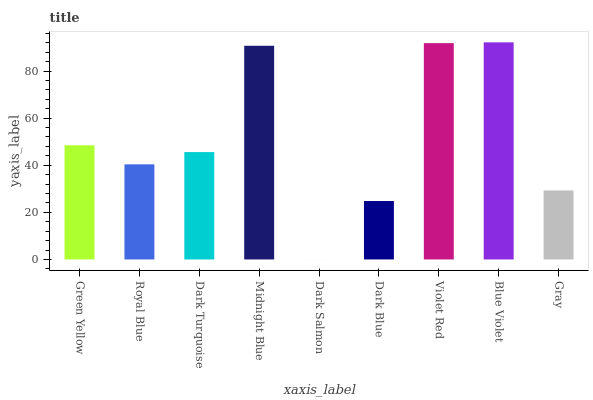Is Royal Blue the minimum?
Answer yes or no. No. Is Royal Blue the maximum?
Answer yes or no. No. Is Green Yellow greater than Royal Blue?
Answer yes or no. Yes. Is Royal Blue less than Green Yellow?
Answer yes or no. Yes. Is Royal Blue greater than Green Yellow?
Answer yes or no. No. Is Green Yellow less than Royal Blue?
Answer yes or no. No. Is Dark Turquoise the high median?
Answer yes or no. Yes. Is Dark Turquoise the low median?
Answer yes or no. Yes. Is Dark Salmon the high median?
Answer yes or no. No. Is Royal Blue the low median?
Answer yes or no. No. 